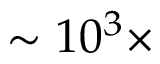<formula> <loc_0><loc_0><loc_500><loc_500>\sim 1 0 ^ { 3 } \times</formula> 